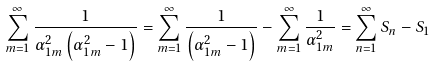Convert formula to latex. <formula><loc_0><loc_0><loc_500><loc_500>\sum _ { m = 1 } ^ { \infty } \frac { 1 } { \alpha _ { 1 m } ^ { 2 } \left ( \alpha _ { 1 m } ^ { 2 } - 1 \right ) } = \sum _ { m = 1 } ^ { \infty } \frac { 1 } { \left ( \alpha _ { 1 m } ^ { 2 } - 1 \right ) } - \sum _ { m = 1 } ^ { \infty } \frac { 1 } { \alpha _ { 1 m } ^ { 2 } } = \sum _ { n = 1 } ^ { \infty } S _ { n } - S _ { 1 }</formula> 